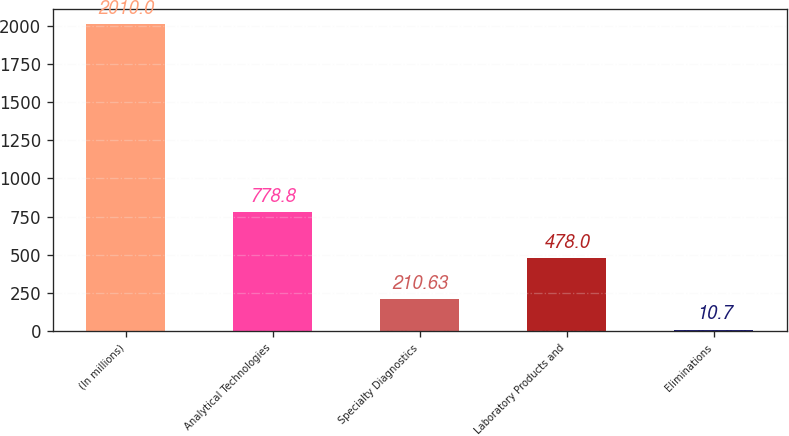<chart> <loc_0><loc_0><loc_500><loc_500><bar_chart><fcel>(In millions)<fcel>Analytical Technologies<fcel>Specialty Diagnostics<fcel>Laboratory Products and<fcel>Eliminations<nl><fcel>2010<fcel>778.8<fcel>210.63<fcel>478<fcel>10.7<nl></chart> 